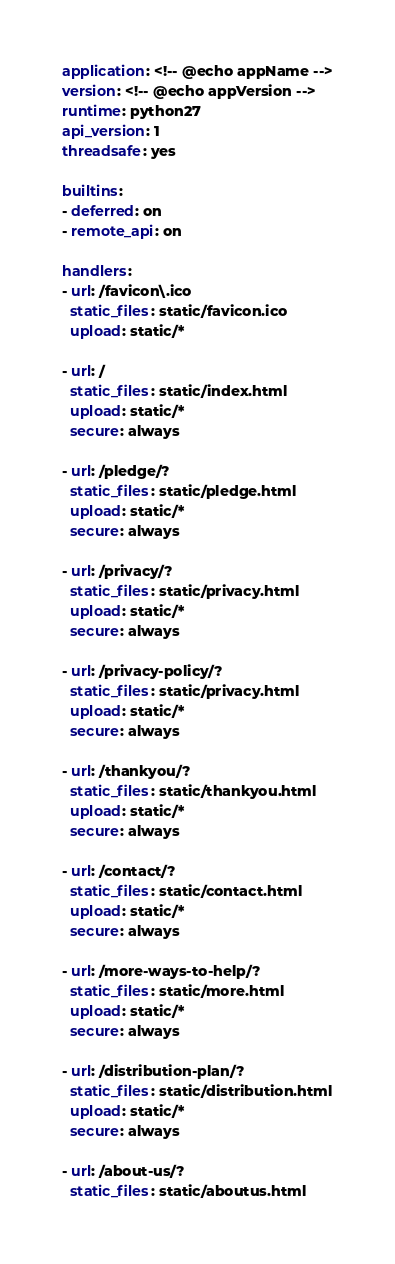Convert code to text. <code><loc_0><loc_0><loc_500><loc_500><_YAML_>application: <!-- @echo appName -->
version: <!-- @echo appVersion -->
runtime: python27
api_version: 1
threadsafe: yes

builtins:
- deferred: on
- remote_api: on

handlers:
- url: /favicon\.ico
  static_files: static/favicon.ico
  upload: static/*

- url: /
  static_files: static/index.html
  upload: static/*
  secure: always

- url: /pledge/?
  static_files: static/pledge.html
  upload: static/*
  secure: always

- url: /privacy/?
  static_files: static/privacy.html
  upload: static/*
  secure: always

- url: /privacy-policy/?
  static_files: static/privacy.html
  upload: static/*
  secure: always

- url: /thankyou/?
  static_files: static/thankyou.html
  upload: static/*
  secure: always

- url: /contact/?
  static_files: static/contact.html
  upload: static/*
  secure: always

- url: /more-ways-to-help/?
  static_files: static/more.html
  upload: static/*
  secure: always

- url: /distribution-plan/?
  static_files: static/distribution.html
  upload: static/*
  secure: always

- url: /about-us/?
  static_files: static/aboutus.html</code> 